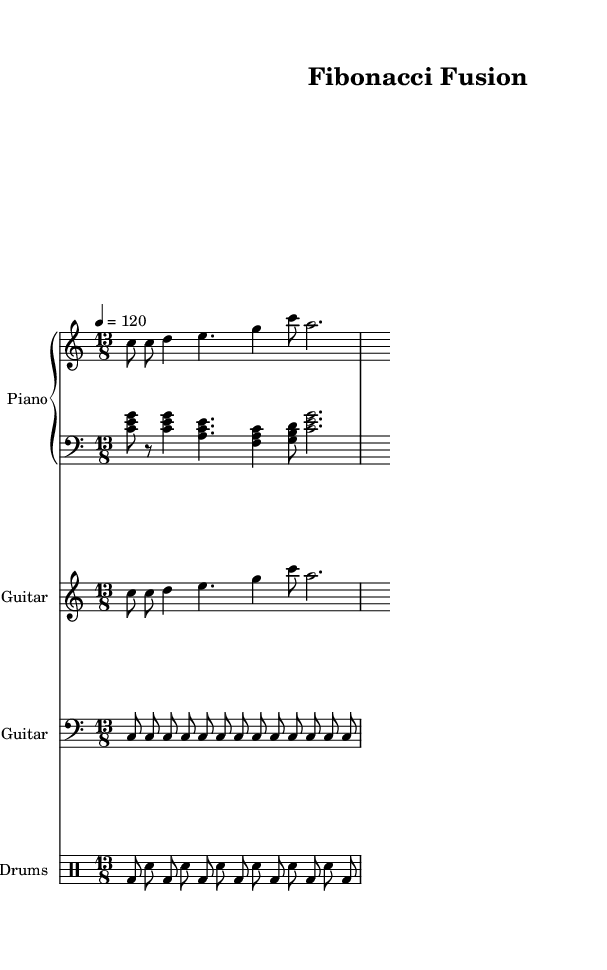What is the time signature of this music? The time signature is indicated at the beginning of the score as 13/8, which means there are 13 beats in each measure, and each eighth note gets one beat.
Answer: 13/8 What is the key signature of this music? The key signature is C major, which has no sharps or flats, as can be inferred from the absence of accidentals on the staff.
Answer: C major What is the tempo marking of this piece? The tempo marking is indicated in the score as a tempo of quarter note equals 120 beats per minute, as noted with the tempo directive at the beginning.
Answer: 120 How many measures are included in the provided music? The code indicates two measures for each part (piano, electric guitar, bass guitar, and drums), totaling eight measures.
Answer: 8 What note value predominates in the bass guitar part? The bass guitar primarily consists of eighth notes based on the rhythm given in the code, which consistently uses the eighth note value throughout.
Answer: Eighth notes What unique rhythmic device is used in this piece that relates to Fibonacci sequences? The piece employs polyrhythms, which relate to Fibonacci sequences in their construction, as Fibonacci numbers often inform rhythmic groupings; this concept reflects the complexity within jazz-rock fusion.
Answer: Polyrhythms How is the left hand of the piano specifically structured? The left hand of the piano utilizes broken chords in a single rhythmic pattern that intersperses rests, creating a fascinating texture that complements the right hand.
Answer: Broken chords 